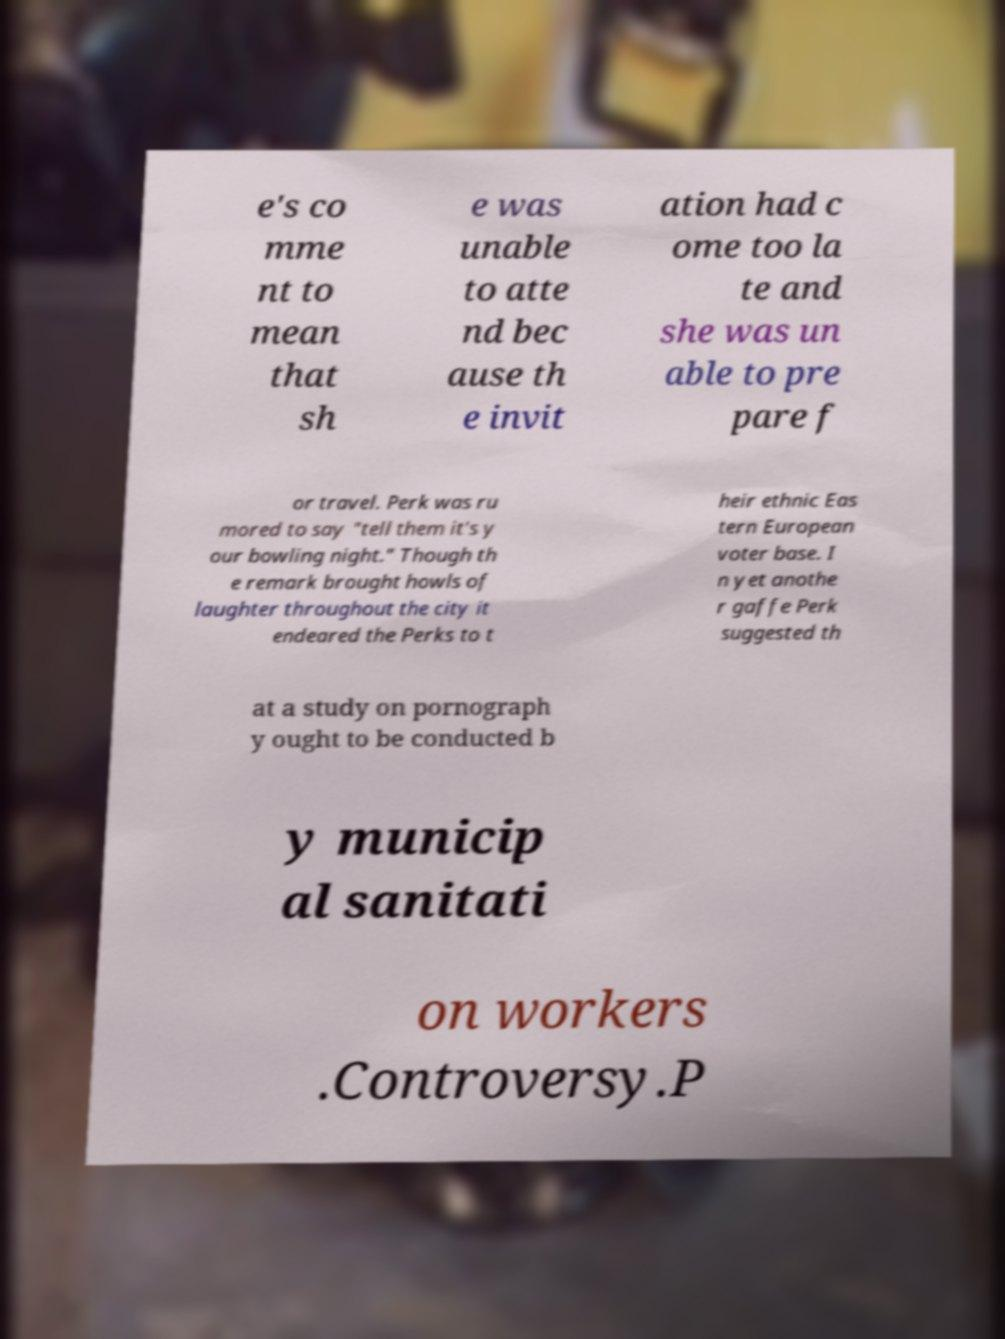Could you assist in decoding the text presented in this image and type it out clearly? e's co mme nt to mean that sh e was unable to atte nd bec ause th e invit ation had c ome too la te and she was un able to pre pare f or travel. Perk was ru mored to say "tell them it's y our bowling night." Though th e remark brought howls of laughter throughout the city it endeared the Perks to t heir ethnic Eas tern European voter base. I n yet anothe r gaffe Perk suggested th at a study on pornograph y ought to be conducted b y municip al sanitati on workers .Controversy.P 